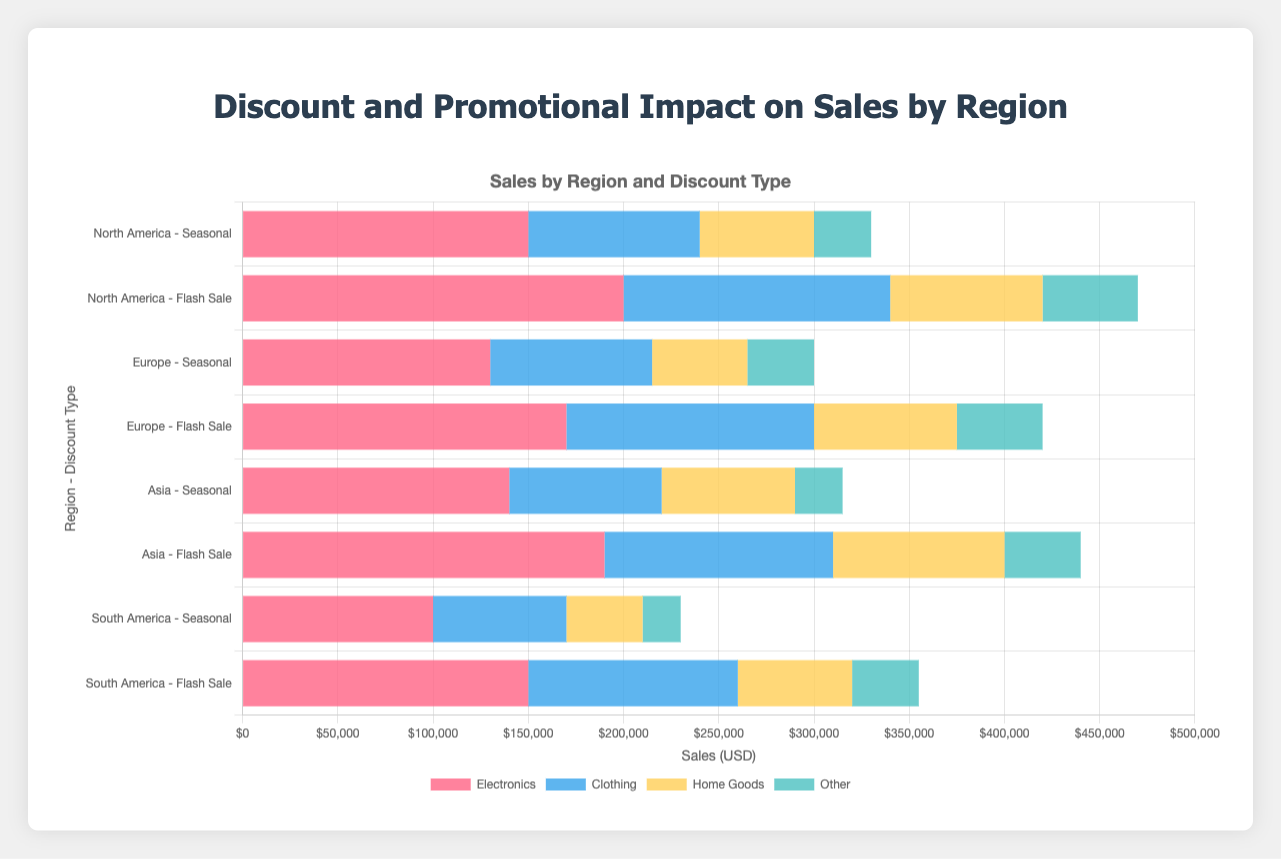What region has the highest electronics sales during a flash sale? North America has the highest electronics sales during a flash sale with 200,000 units. We can determine this by comparing the red bar's length (representing electronics) for flash sales in each region.
Answer: North America Which region has the smallest difference in electronics sales between seasonal and flash sales? Seasonally, North America has 150,000 sales and during flash sales, 200,000 sales, a difference of 50,000. Similarly, Europe has a difference of 40,000 (Seasonal: 130,000, Flash: 170,000); Asia 50,000 (Seasonal: 140,000, Flash: 190,000); and South America 50,000 (Seasonal: 100,000, Flash: 150,000). Thus, Europe has the smallest difference (40,000).
Answer: Europe What is the total sales across all categories for Europe under seasonal discounts? Adding all the sales categories for Europe under seasonal discounts: electronics (130,000) + clothing (85,000) + home goods (50,000) + other (35,000) produces a total of 300,000.
Answer: 300,000 Between seasonal and flash sales, which discount type boosted home goods sales the most in South America? For South America, seasonal promotions showed 40,000 sales in home goods, while flash sales showed 60,000. Flash sales boosted home goods the most.
Answer: Flash Sales What is the difference in total sales between seasonal and flash sales for Asia? Total sales under seasonal are: electronics (140,000) + clothing (80,000) + home goods (70,000) + other (25,000) = 315,000. Under flash sales, the total is: electronics (190,000) + clothing (120,000) + home goods (90,000) + other (40,000) = 440,000. Therefore, the difference is 440,000 - 315,000 = 125,000.
Answer: 125,000 Which category shows the highest sales increase in North America when moving from seasonal to flash sale discounts? Comparing seasonal and flash sales for North America: electronics increase by 200,000 - 150,000 = 50,000; clothing by 140,000 - 90,000 = 50,000; home goods by 80,000 - 60,000 = 20,000; and other by 50,000 - 30,000 = 20,000. Thus, electronics and clothing both have the highest increase (50,000).
Answer: Electronics and Clothing Comparing regions, which had the highest sales for clothing during a flash sale? Looking at the blue bars for clothing sales in flash sales, North America reported 140,000, Europe 130,000, Asia 120,000 and South America 110,000. Thus, North America had the highest clothing sales.
Answer: North America Is the promotional impact (increase in sales) greater for flash sales or seasonal discounts in Europe for home goods? In Europe, home goods sales increased from 50,000 under seasonal to 75,000 for flash sales, an increase of 25,000. Therefore, the flash sale has a greater impact.
Answer: Flash Sales 